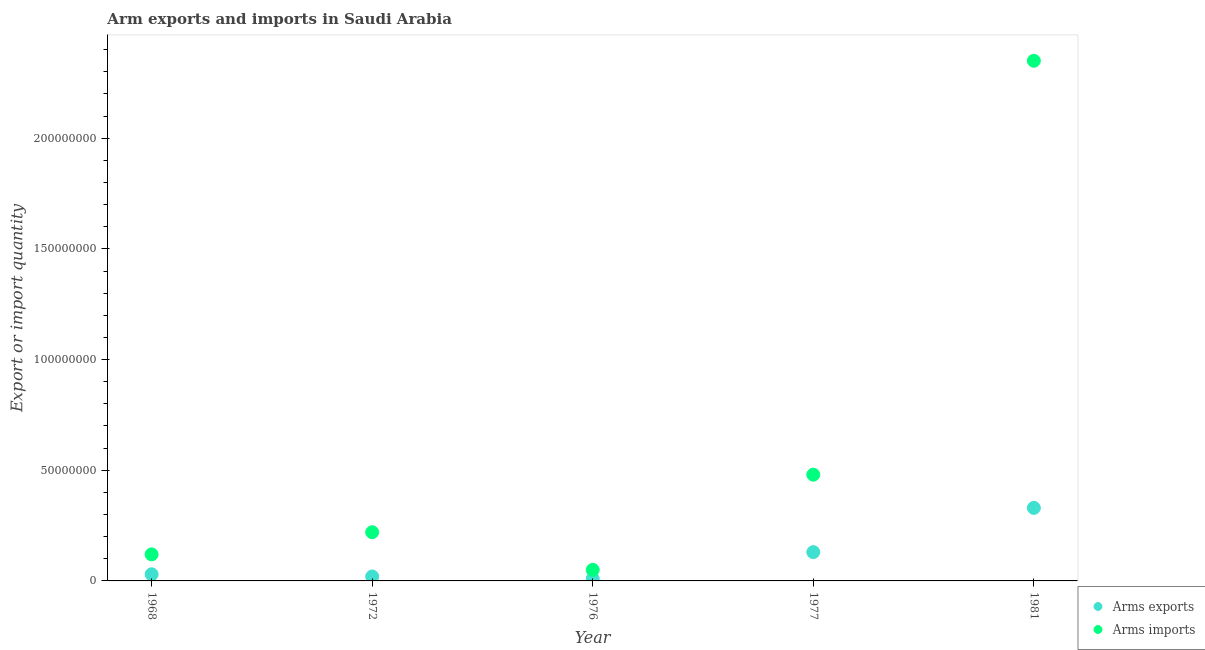How many different coloured dotlines are there?
Offer a terse response. 2. What is the arms imports in 1968?
Provide a succinct answer. 1.20e+07. Across all years, what is the maximum arms imports?
Offer a very short reply. 2.35e+08. Across all years, what is the minimum arms imports?
Offer a terse response. 5.00e+06. In which year was the arms imports maximum?
Offer a very short reply. 1981. In which year was the arms imports minimum?
Your response must be concise. 1976. What is the total arms exports in the graph?
Your answer should be very brief. 5.20e+07. What is the difference between the arms imports in 1976 and that in 1977?
Make the answer very short. -4.30e+07. What is the difference between the arms exports in 1981 and the arms imports in 1968?
Your answer should be very brief. 2.10e+07. What is the average arms exports per year?
Your answer should be very brief. 1.04e+07. In the year 1976, what is the difference between the arms imports and arms exports?
Give a very brief answer. 4.00e+06. Is the arms exports in 1968 less than that in 1981?
Provide a short and direct response. Yes. What is the difference between the highest and the lowest arms imports?
Provide a succinct answer. 2.30e+08. In how many years, is the arms exports greater than the average arms exports taken over all years?
Offer a very short reply. 2. Is the sum of the arms imports in 1968 and 1977 greater than the maximum arms exports across all years?
Provide a succinct answer. Yes. What is the difference between two consecutive major ticks on the Y-axis?
Your answer should be compact. 5.00e+07. Are the values on the major ticks of Y-axis written in scientific E-notation?
Your answer should be very brief. No. Does the graph contain any zero values?
Offer a terse response. No. Does the graph contain grids?
Your answer should be very brief. No. How are the legend labels stacked?
Provide a short and direct response. Vertical. What is the title of the graph?
Provide a short and direct response. Arm exports and imports in Saudi Arabia. What is the label or title of the Y-axis?
Provide a succinct answer. Export or import quantity. What is the Export or import quantity of Arms exports in 1968?
Offer a very short reply. 3.00e+06. What is the Export or import quantity of Arms imports in 1968?
Your response must be concise. 1.20e+07. What is the Export or import quantity in Arms imports in 1972?
Ensure brevity in your answer.  2.20e+07. What is the Export or import quantity of Arms exports in 1977?
Your answer should be very brief. 1.30e+07. What is the Export or import quantity in Arms imports in 1977?
Offer a very short reply. 4.80e+07. What is the Export or import quantity in Arms exports in 1981?
Provide a short and direct response. 3.30e+07. What is the Export or import quantity of Arms imports in 1981?
Offer a very short reply. 2.35e+08. Across all years, what is the maximum Export or import quantity of Arms exports?
Provide a succinct answer. 3.30e+07. Across all years, what is the maximum Export or import quantity of Arms imports?
Ensure brevity in your answer.  2.35e+08. What is the total Export or import quantity of Arms exports in the graph?
Your response must be concise. 5.20e+07. What is the total Export or import quantity of Arms imports in the graph?
Ensure brevity in your answer.  3.22e+08. What is the difference between the Export or import quantity of Arms exports in 1968 and that in 1972?
Make the answer very short. 1.00e+06. What is the difference between the Export or import quantity of Arms imports in 1968 and that in 1972?
Your answer should be compact. -1.00e+07. What is the difference between the Export or import quantity in Arms exports in 1968 and that in 1977?
Make the answer very short. -1.00e+07. What is the difference between the Export or import quantity of Arms imports in 1968 and that in 1977?
Your response must be concise. -3.60e+07. What is the difference between the Export or import quantity in Arms exports in 1968 and that in 1981?
Make the answer very short. -3.00e+07. What is the difference between the Export or import quantity in Arms imports in 1968 and that in 1981?
Your response must be concise. -2.23e+08. What is the difference between the Export or import quantity of Arms exports in 1972 and that in 1976?
Keep it short and to the point. 1.00e+06. What is the difference between the Export or import quantity of Arms imports in 1972 and that in 1976?
Make the answer very short. 1.70e+07. What is the difference between the Export or import quantity in Arms exports in 1972 and that in 1977?
Offer a very short reply. -1.10e+07. What is the difference between the Export or import quantity of Arms imports in 1972 and that in 1977?
Your answer should be very brief. -2.60e+07. What is the difference between the Export or import quantity in Arms exports in 1972 and that in 1981?
Provide a succinct answer. -3.10e+07. What is the difference between the Export or import quantity in Arms imports in 1972 and that in 1981?
Make the answer very short. -2.13e+08. What is the difference between the Export or import quantity in Arms exports in 1976 and that in 1977?
Make the answer very short. -1.20e+07. What is the difference between the Export or import quantity of Arms imports in 1976 and that in 1977?
Offer a terse response. -4.30e+07. What is the difference between the Export or import quantity of Arms exports in 1976 and that in 1981?
Keep it short and to the point. -3.20e+07. What is the difference between the Export or import quantity in Arms imports in 1976 and that in 1981?
Offer a terse response. -2.30e+08. What is the difference between the Export or import quantity of Arms exports in 1977 and that in 1981?
Keep it short and to the point. -2.00e+07. What is the difference between the Export or import quantity of Arms imports in 1977 and that in 1981?
Offer a terse response. -1.87e+08. What is the difference between the Export or import quantity in Arms exports in 1968 and the Export or import quantity in Arms imports in 1972?
Make the answer very short. -1.90e+07. What is the difference between the Export or import quantity in Arms exports in 1968 and the Export or import quantity in Arms imports in 1977?
Keep it short and to the point. -4.50e+07. What is the difference between the Export or import quantity in Arms exports in 1968 and the Export or import quantity in Arms imports in 1981?
Ensure brevity in your answer.  -2.32e+08. What is the difference between the Export or import quantity in Arms exports in 1972 and the Export or import quantity in Arms imports in 1976?
Your response must be concise. -3.00e+06. What is the difference between the Export or import quantity in Arms exports in 1972 and the Export or import quantity in Arms imports in 1977?
Offer a terse response. -4.60e+07. What is the difference between the Export or import quantity of Arms exports in 1972 and the Export or import quantity of Arms imports in 1981?
Offer a terse response. -2.33e+08. What is the difference between the Export or import quantity in Arms exports in 1976 and the Export or import quantity in Arms imports in 1977?
Your answer should be very brief. -4.70e+07. What is the difference between the Export or import quantity in Arms exports in 1976 and the Export or import quantity in Arms imports in 1981?
Provide a succinct answer. -2.34e+08. What is the difference between the Export or import quantity in Arms exports in 1977 and the Export or import quantity in Arms imports in 1981?
Give a very brief answer. -2.22e+08. What is the average Export or import quantity in Arms exports per year?
Offer a very short reply. 1.04e+07. What is the average Export or import quantity in Arms imports per year?
Your response must be concise. 6.44e+07. In the year 1968, what is the difference between the Export or import quantity in Arms exports and Export or import quantity in Arms imports?
Ensure brevity in your answer.  -9.00e+06. In the year 1972, what is the difference between the Export or import quantity in Arms exports and Export or import quantity in Arms imports?
Provide a succinct answer. -2.00e+07. In the year 1977, what is the difference between the Export or import quantity of Arms exports and Export or import quantity of Arms imports?
Your answer should be compact. -3.50e+07. In the year 1981, what is the difference between the Export or import quantity in Arms exports and Export or import quantity in Arms imports?
Your response must be concise. -2.02e+08. What is the ratio of the Export or import quantity of Arms exports in 1968 to that in 1972?
Offer a terse response. 1.5. What is the ratio of the Export or import quantity of Arms imports in 1968 to that in 1972?
Ensure brevity in your answer.  0.55. What is the ratio of the Export or import quantity in Arms exports in 1968 to that in 1976?
Provide a short and direct response. 3. What is the ratio of the Export or import quantity in Arms exports in 1968 to that in 1977?
Ensure brevity in your answer.  0.23. What is the ratio of the Export or import quantity of Arms exports in 1968 to that in 1981?
Provide a succinct answer. 0.09. What is the ratio of the Export or import quantity of Arms imports in 1968 to that in 1981?
Provide a succinct answer. 0.05. What is the ratio of the Export or import quantity of Arms exports in 1972 to that in 1976?
Offer a very short reply. 2. What is the ratio of the Export or import quantity in Arms exports in 1972 to that in 1977?
Offer a terse response. 0.15. What is the ratio of the Export or import quantity of Arms imports in 1972 to that in 1977?
Make the answer very short. 0.46. What is the ratio of the Export or import quantity in Arms exports in 1972 to that in 1981?
Make the answer very short. 0.06. What is the ratio of the Export or import quantity in Arms imports in 1972 to that in 1981?
Provide a succinct answer. 0.09. What is the ratio of the Export or import quantity in Arms exports in 1976 to that in 1977?
Your response must be concise. 0.08. What is the ratio of the Export or import quantity of Arms imports in 1976 to that in 1977?
Provide a short and direct response. 0.1. What is the ratio of the Export or import quantity of Arms exports in 1976 to that in 1981?
Ensure brevity in your answer.  0.03. What is the ratio of the Export or import quantity of Arms imports in 1976 to that in 1981?
Your answer should be compact. 0.02. What is the ratio of the Export or import quantity in Arms exports in 1977 to that in 1981?
Provide a succinct answer. 0.39. What is the ratio of the Export or import quantity in Arms imports in 1977 to that in 1981?
Provide a short and direct response. 0.2. What is the difference between the highest and the second highest Export or import quantity of Arms exports?
Ensure brevity in your answer.  2.00e+07. What is the difference between the highest and the second highest Export or import quantity in Arms imports?
Offer a terse response. 1.87e+08. What is the difference between the highest and the lowest Export or import quantity of Arms exports?
Make the answer very short. 3.20e+07. What is the difference between the highest and the lowest Export or import quantity in Arms imports?
Provide a succinct answer. 2.30e+08. 